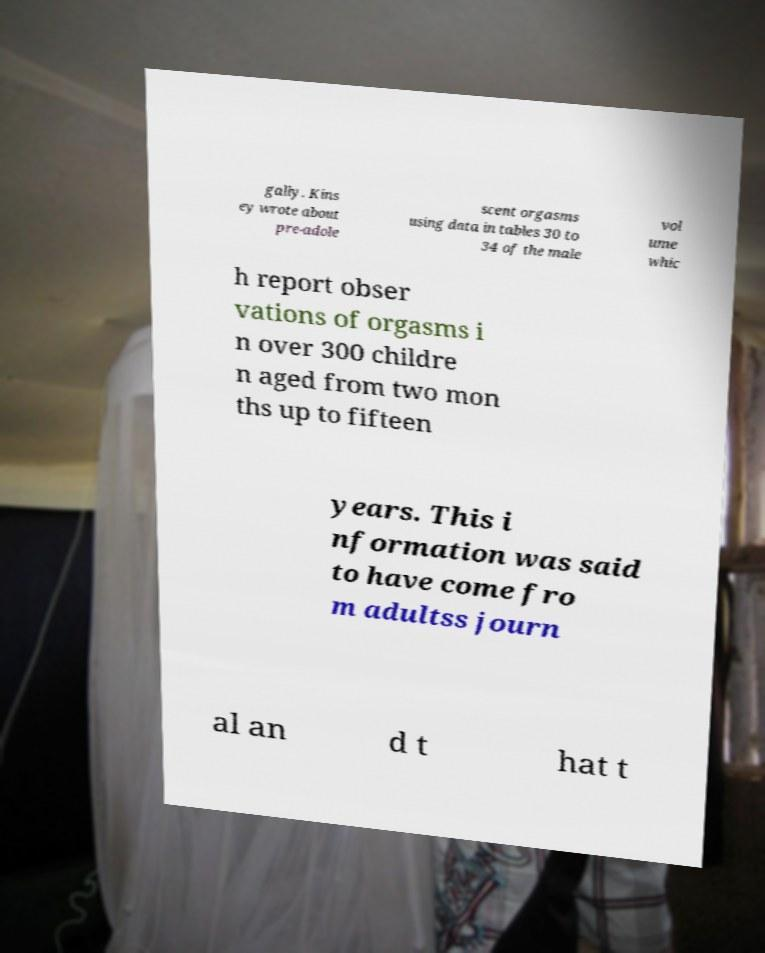Can you read and provide the text displayed in the image?This photo seems to have some interesting text. Can you extract and type it out for me? gally. Kins ey wrote about pre-adole scent orgasms using data in tables 30 to 34 of the male vol ume whic h report obser vations of orgasms i n over 300 childre n aged from two mon ths up to fifteen years. This i nformation was said to have come fro m adultss journ al an d t hat t 